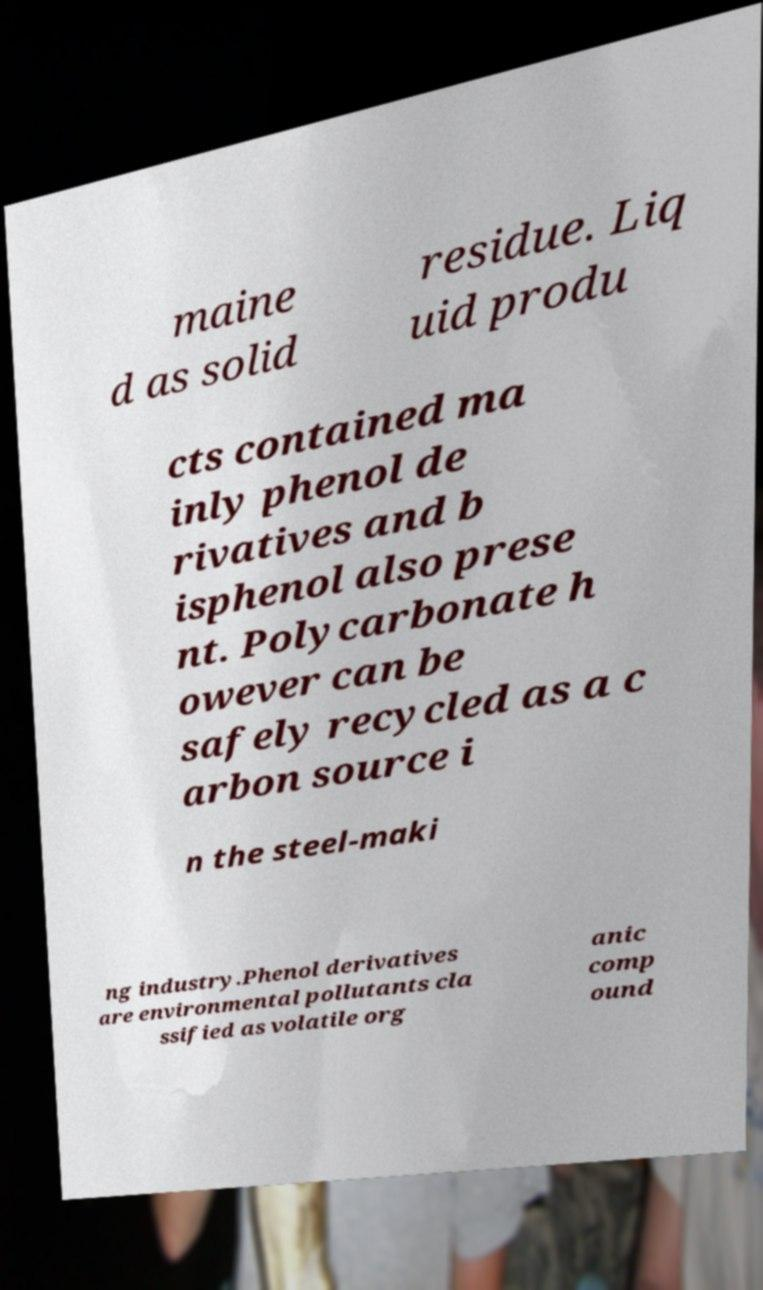Please identify and transcribe the text found in this image. maine d as solid residue. Liq uid produ cts contained ma inly phenol de rivatives and b isphenol also prese nt. Polycarbonate h owever can be safely recycled as a c arbon source i n the steel-maki ng industry.Phenol derivatives are environmental pollutants cla ssified as volatile org anic comp ound 